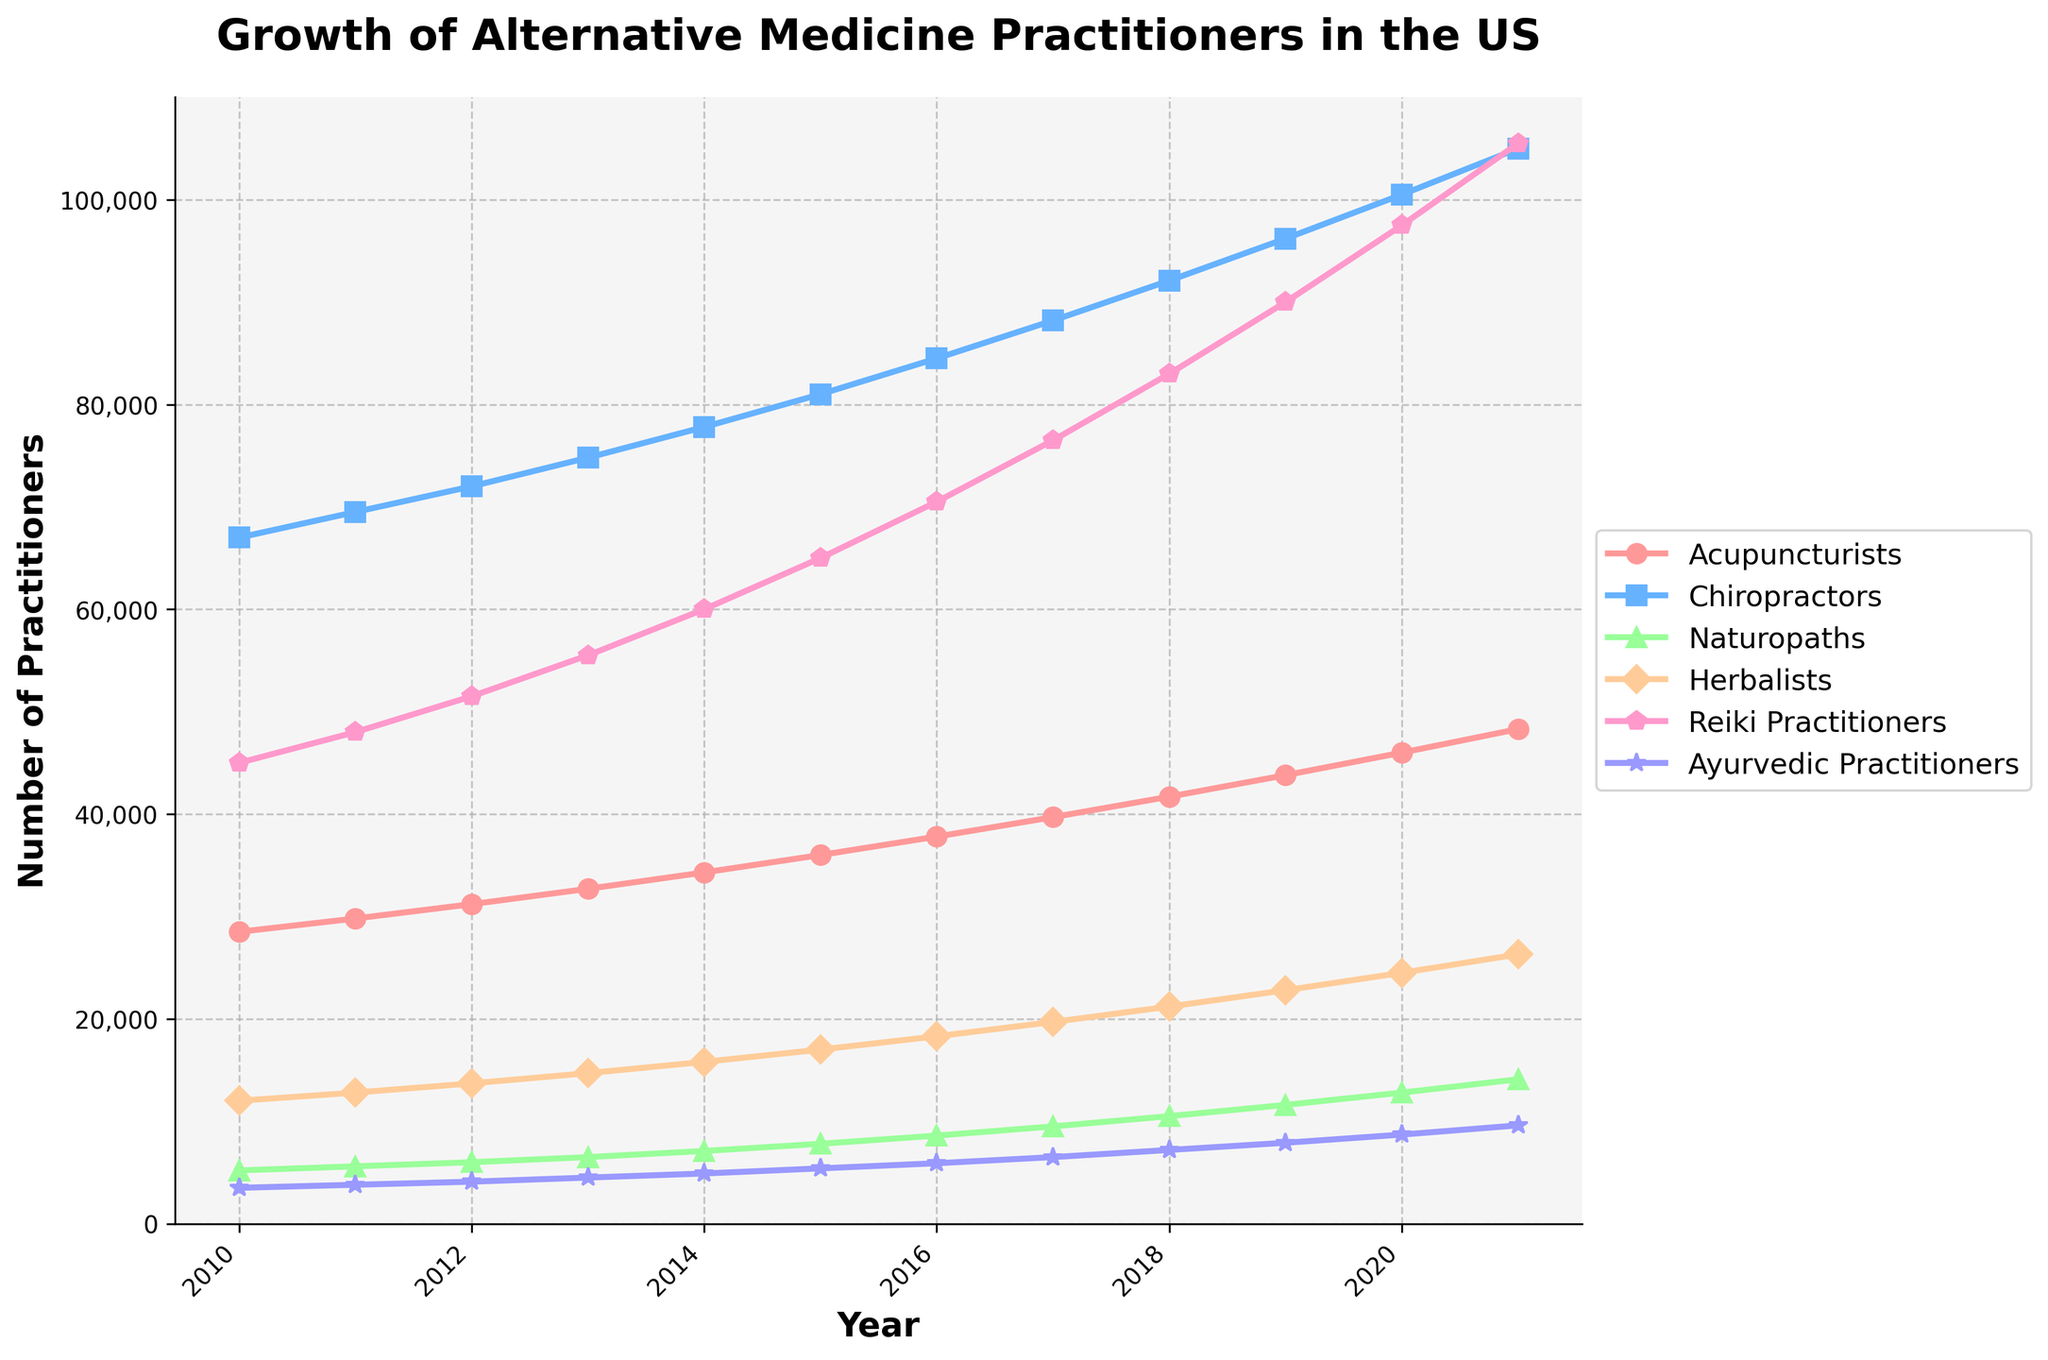What was the total number of alternative medicine practitioners in 2015? To find the total number of practitioners in 2015, sum up the values of all specialties for that year: Acupuncturists (36000) + Chiropractors (81000) + Naturopaths (7800) + Herbalists (17000) + Reiki Practitioners (65000) + Ayurvedic Practitioners (5400) = 213,200.
Answer: 213,200 Which specialty experienced the highest growth rate between 2010 and 2021? To determine the highest growth rate, calculate the growth for each specialty between 2010 and 2021. The highest increase is seen in Reiki Practitioners: 105,500 (2021) - 45,000 (2010) = 60,500. Compare this with the growth of other specialties to verify.
Answer: Reiki Practitioners In which year do Herbalists surpass 20,000 practitioners for the first time? Observe the trend line for Herbalists. Identify the year when the number crosses the 20,000 mark. The graph shows that in 2018, Herbalists had 21,200 practitioners, marking the first crossing of 20,000.
Answer: 2018 By how much did the number of Naturopaths increase between 2015 and 2020? Calculate the difference in the number of Naturopaths between 2020 and 2015: 12,800 (2020) - 7,800 (2015) = 5,000.
Answer: 5,000 Which specialty had the least growth in absolute numbers from 2010 to 2021? To find the least growth, look at the increases for each specialty from 2010 to 2021 and determine the smallest one. Ayurvedic Practitioners increased from 3,500 to 9,600, which is an increase of 6,100, the smallest among all specialties.
Answer: Ayurvedic Practitioners How does the number of Acupuncturists in 2018 compare to that in 2010? Compare the number of Acupuncturists in 2018 (41,700) to 2010 (28,500). This corresponds to an increase of 13,200 practitioners.
Answer: Increased by 13,200 What is the percentage increase in the number of Chiropractors from 2010 to 2021? Calculate the percentage increase: (105,000 - 67,000) / 67,000 * 100% = 56.72%.
Answer: 56.72% Which year marked the first instance when Reiki Practitioners' numbers exceeded 80,000? Check the graph for Reiki Practitioners and find the year when it first surpasses 80,000. In 2018, Reiki Practitioners are 83,000.
Answer: 2018 Compare the number of Ayurvedic Practitioners to Acupuncturists in 2021. Compare the figures for 2021, where Ayurvedic Practitioners are 9,600 and Acupuncturists are 48,300. Acupuncturists greatly outnumber Ayurvedic Practitioners.
Answer: Acupuncturists outnumber by 38,700 